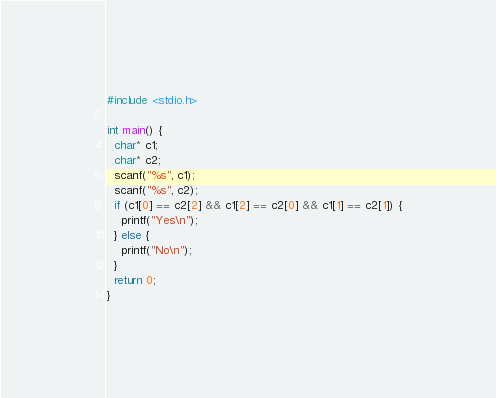Convert code to text. <code><loc_0><loc_0><loc_500><loc_500><_C_>#include <stdio.h>
     
int main() {
  char* c1;
  char* c2;
  scanf("%s", c1);
  scanf("%s", c2);
  if (c1[0] == c2[2] && c1[2] == c2[0] && c1[1] == c2[1]) {
    printf("Yes\n");
  } else {
    printf("No\n");
  }
  return 0;
}</code> 